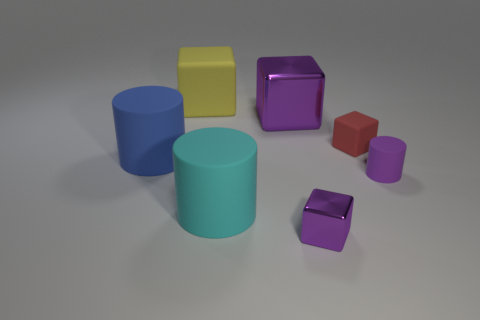Subtract all small purple cubes. How many cubes are left? 3 Subtract all red blocks. How many blocks are left? 3 Add 2 large cyan matte cylinders. How many objects exist? 9 Subtract 2 cylinders. How many cylinders are left? 1 Subtract 0 green cubes. How many objects are left? 7 Subtract all cylinders. How many objects are left? 4 Subtract all cyan cylinders. Subtract all yellow balls. How many cylinders are left? 2 Subtract all gray cylinders. How many purple blocks are left? 2 Subtract all big cyan things. Subtract all matte things. How many objects are left? 1 Add 3 tiny purple matte objects. How many tiny purple matte objects are left? 4 